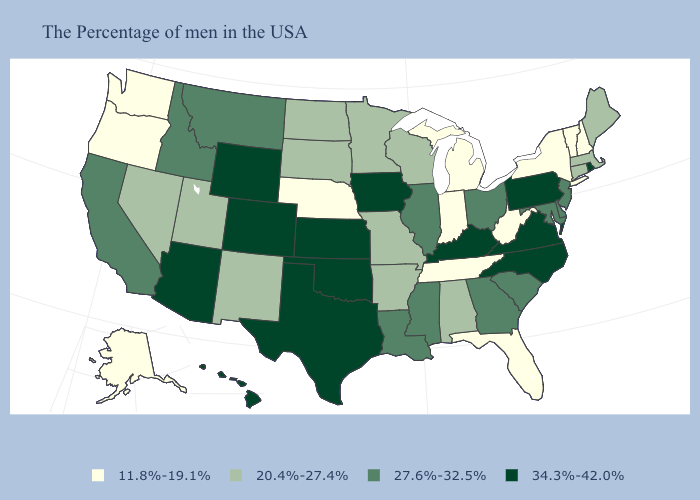How many symbols are there in the legend?
Keep it brief. 4. What is the value of Arizona?
Concise answer only. 34.3%-42.0%. What is the highest value in the USA?
Concise answer only. 34.3%-42.0%. What is the highest value in the South ?
Keep it brief. 34.3%-42.0%. What is the highest value in the USA?
Short answer required. 34.3%-42.0%. What is the lowest value in states that border Nebraska?
Be succinct. 20.4%-27.4%. Does the map have missing data?
Answer briefly. No. Among the states that border Oregon , which have the lowest value?
Be succinct. Washington. What is the highest value in states that border Arkansas?
Be succinct. 34.3%-42.0%. What is the value of Hawaii?
Give a very brief answer. 34.3%-42.0%. What is the value of New Hampshire?
Quick response, please. 11.8%-19.1%. Name the states that have a value in the range 11.8%-19.1%?
Be succinct. New Hampshire, Vermont, New York, West Virginia, Florida, Michigan, Indiana, Tennessee, Nebraska, Washington, Oregon, Alaska. What is the value of Texas?
Give a very brief answer. 34.3%-42.0%. What is the lowest value in the South?
Quick response, please. 11.8%-19.1%. 